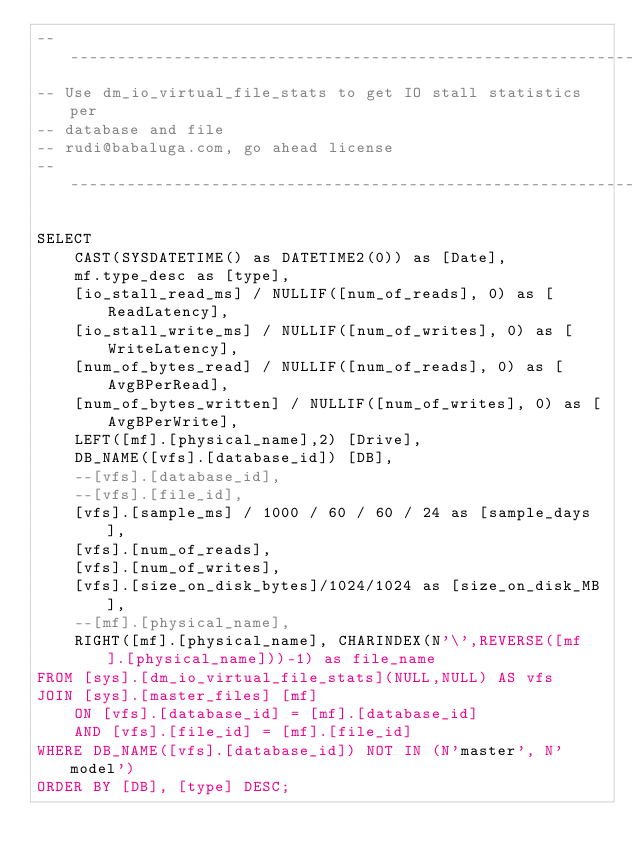Convert code to text. <code><loc_0><loc_0><loc_500><loc_500><_SQL_>-----------------------------------------------------------------
-- Use dm_io_virtual_file_stats to get IO stall statistics per
-- database and file
-- rudi@babaluga.com, go ahead license
-----------------------------------------------------------------

SELECT 
	CAST(SYSDATETIME() as DATETIME2(0)) as [Date],
	mf.type_desc as [type],
	[io_stall_read_ms] / NULLIF([num_of_reads], 0) as [ReadLatency],
	[io_stall_write_ms] / NULLIF([num_of_writes], 0) as [WriteLatency],
	[num_of_bytes_read] / NULLIF([num_of_reads], 0) as [AvgBPerRead],
	[num_of_bytes_written] / NULLIF([num_of_writes], 0) as [AvgBPerWrite],
	LEFT([mf].[physical_name],2) [Drive],
	DB_NAME([vfs].[database_id]) [DB],
	--[vfs].[database_id],
	--[vfs].[file_id],
	[vfs].[sample_ms] / 1000 / 60 / 60 / 24 as [sample_days],
	[vfs].[num_of_reads],
	[vfs].[num_of_writes],
	[vfs].[size_on_disk_bytes]/1024/1024 as [size_on_disk_MB],
	--[mf].[physical_name],
	RIGHT([mf].[physical_name], CHARINDEX(N'\',REVERSE([mf].[physical_name]))-1) as file_name
FROM [sys].[dm_io_virtual_file_stats](NULL,NULL) AS vfs
JOIN [sys].[master_files] [mf] 
    ON [vfs].[database_id] = [mf].[database_id] 
    AND [vfs].[file_id] = [mf].[file_id]
WHERE DB_NAME([vfs].[database_id]) NOT IN (N'master', N'model')
ORDER BY [DB], [type] DESC;</code> 